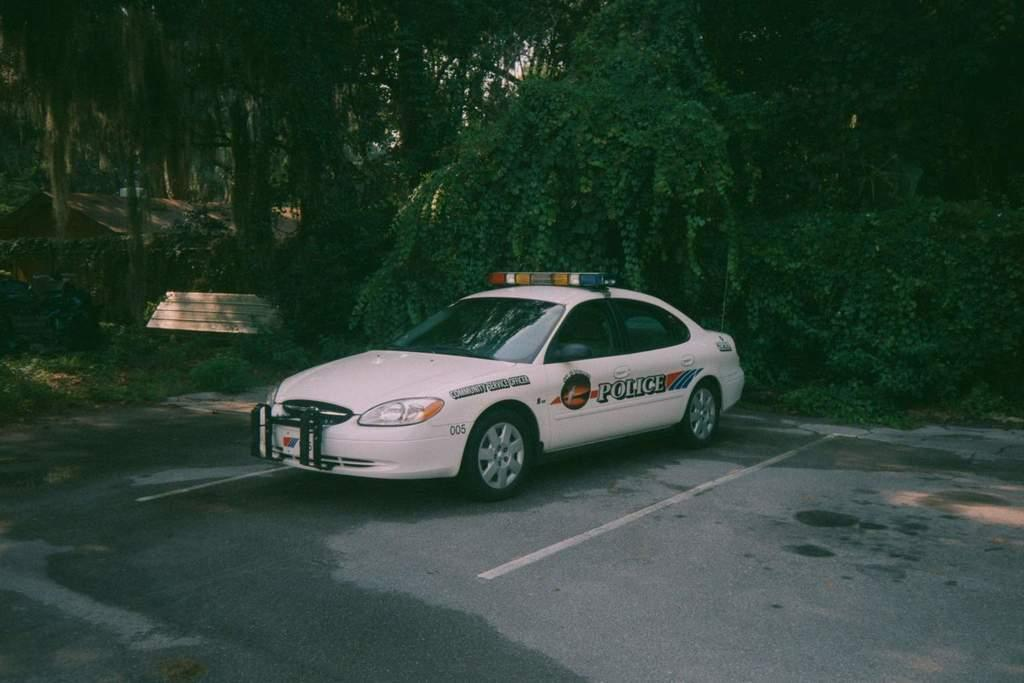What is the main subject of the image? The main subject of the image is a car. Where is the car located in the image? The car is parked on the road in the image. What can be seen in the background of the image? Trees and the sky are visible in the background of the image. What type of music can be heard coming from the car in the image? There is no indication of any music in the image, as it only shows a parked car on the road. 